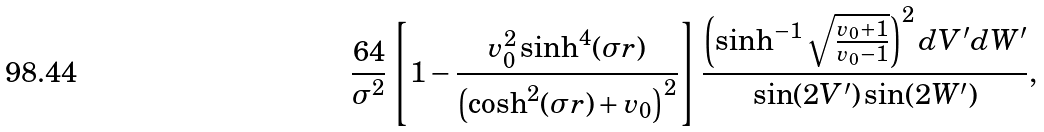<formula> <loc_0><loc_0><loc_500><loc_500>\frac { 6 4 } { \sigma ^ { 2 } } \left [ 1 - \frac { v _ { 0 } ^ { 2 } \sinh ^ { 4 } ( \sigma r ) } { \left ( \cosh ^ { 2 } ( \sigma r ) + v _ { 0 } \right ) ^ { 2 } } \right ] \frac { \left ( \sinh ^ { - 1 } \sqrt { \frac { v _ { 0 } + 1 } { v _ { 0 } - 1 } } \right ) ^ { 2 } d V ^ { \prime } d W ^ { \prime } } { \sin ( 2 V ^ { \prime } ) \sin ( 2 W ^ { \prime } ) } ,</formula> 